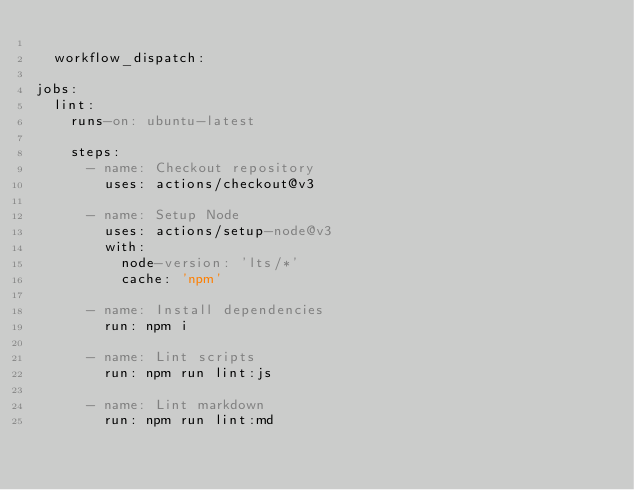Convert code to text. <code><loc_0><loc_0><loc_500><loc_500><_YAML_>
  workflow_dispatch:

jobs:
  lint:
    runs-on: ubuntu-latest

    steps:
      - name: Checkout repository
        uses: actions/checkout@v3

      - name: Setup Node
        uses: actions/setup-node@v3
        with:
          node-version: 'lts/*'
          cache: 'npm'

      - name: Install dependencies
        run: npm i

      - name: Lint scripts
        run: npm run lint:js

      - name: Lint markdown
        run: npm run lint:md
</code> 